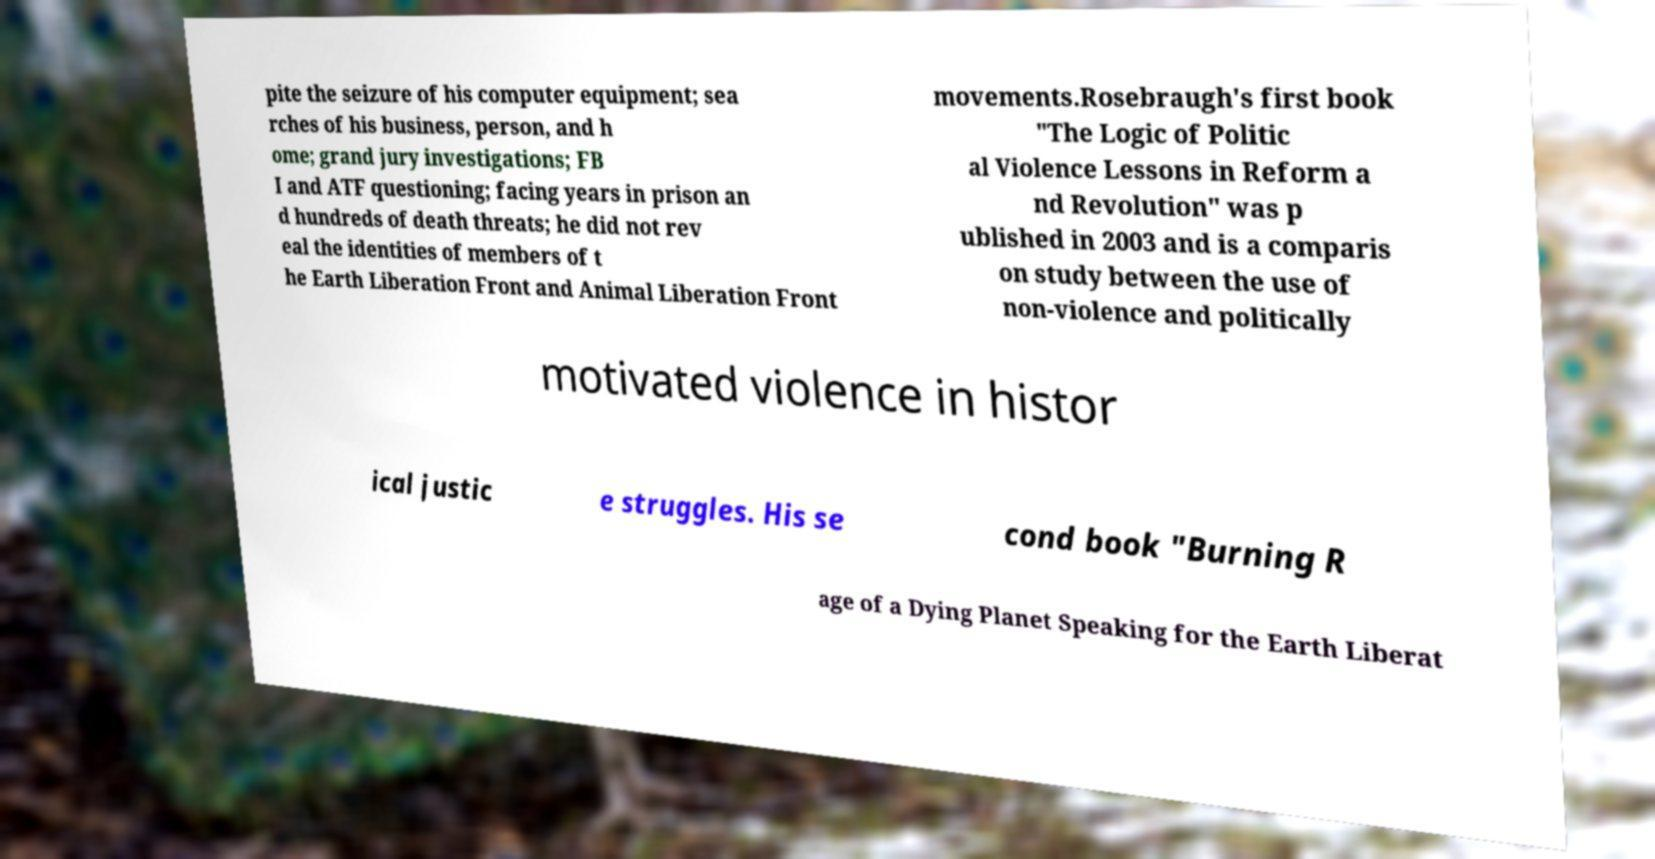Could you extract and type out the text from this image? pite the seizure of his computer equipment; sea rches of his business, person, and h ome; grand jury investigations; FB I and ATF questioning; facing years in prison an d hundreds of death threats; he did not rev eal the identities of members of t he Earth Liberation Front and Animal Liberation Front movements.Rosebraugh's first book "The Logic of Politic al Violence Lessons in Reform a nd Revolution" was p ublished in 2003 and is a comparis on study between the use of non-violence and politically motivated violence in histor ical justic e struggles. His se cond book "Burning R age of a Dying Planet Speaking for the Earth Liberat 